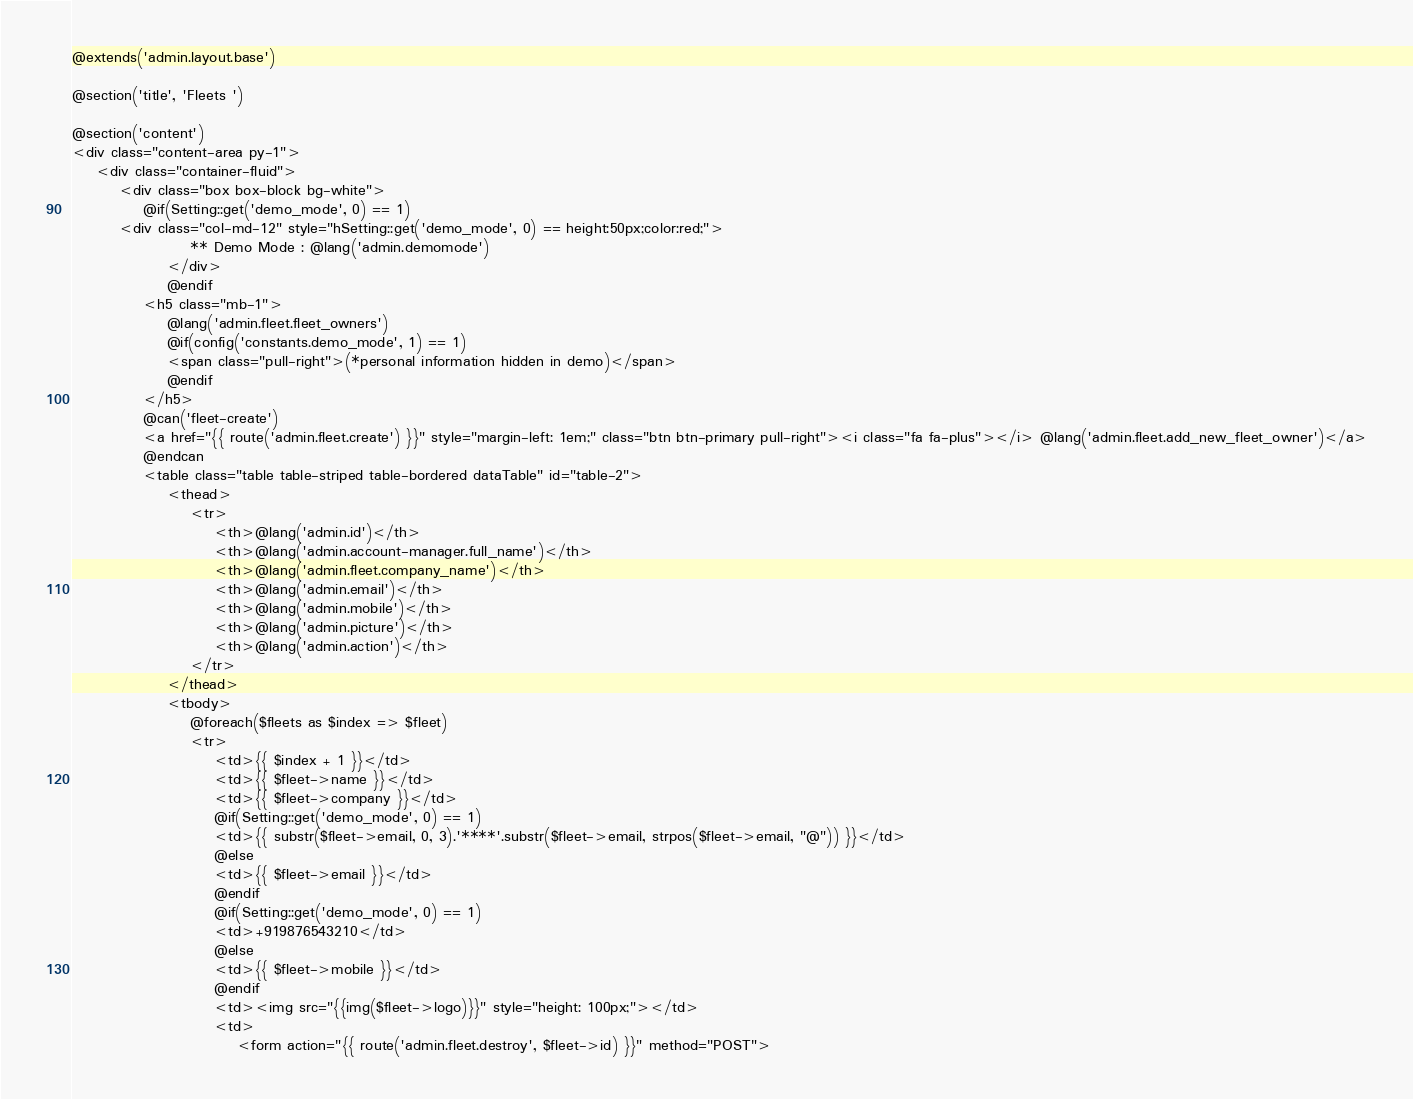Convert code to text. <code><loc_0><loc_0><loc_500><loc_500><_PHP_>@extends('admin.layout.base')

@section('title', 'Fleets ')

@section('content')
<div class="content-area py-1">
    <div class="container-fluid">
        <div class="box box-block bg-white">
            @if(Setting::get('demo_mode', 0) == 1)
        <div class="col-md-12" style="hSetting::get('demo_mode', 0) == height:50px;color:red;">
                    ** Demo Mode : @lang('admin.demomode')
                </div>
                @endif
            <h5 class="mb-1">
                @lang('admin.fleet.fleet_owners')
                @if(config('constants.demo_mode', 1) == 1)
                <span class="pull-right">(*personal information hidden in demo)</span>
                @endif
            </h5>
            @can('fleet-create')
            <a href="{{ route('admin.fleet.create') }}" style="margin-left: 1em;" class="btn btn-primary pull-right"><i class="fa fa-plus"></i> @lang('admin.fleet.add_new_fleet_owner')</a>
            @endcan
            <table class="table table-striped table-bordered dataTable" id="table-2">
                <thead>
                    <tr>
                        <th>@lang('admin.id')</th>
                        <th>@lang('admin.account-manager.full_name')</th>
                        <th>@lang('admin.fleet.company_name')</th>
                        <th>@lang('admin.email')</th>
                        <th>@lang('admin.mobile')</th>
                        <th>@lang('admin.picture')</th>
                        <th>@lang('admin.action')</th>
                    </tr>
                </thead>
                <tbody>
                    @foreach($fleets as $index => $fleet)
                    <tr>
                        <td>{{ $index + 1 }}</td>
                        <td>{{ $fleet->name }}</td>
                        <td>{{ $fleet->company }}</td>
                        @if(Setting::get('demo_mode', 0) == 1)
                        <td>{{ substr($fleet->email, 0, 3).'****'.substr($fleet->email, strpos($fleet->email, "@")) }}</td>
                        @else
                        <td>{{ $fleet->email }}</td>
                        @endif
                        @if(Setting::get('demo_mode', 0) == 1)
                        <td>+919876543210</td>
                        @else
                        <td>{{ $fleet->mobile }}</td>
                        @endif
                        <td><img src="{{img($fleet->logo)}}" style="height: 100px;"></td>
                        <td>
                            <form action="{{ route('admin.fleet.destroy', $fleet->id) }}" method="POST"></code> 